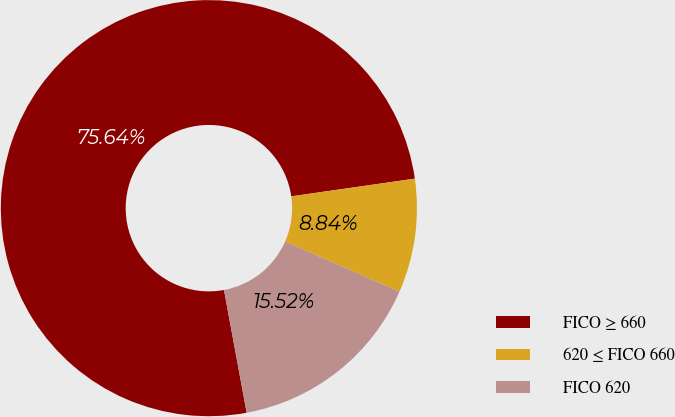Convert chart to OTSL. <chart><loc_0><loc_0><loc_500><loc_500><pie_chart><fcel>FICO ≥ 660<fcel>620 ≤ FICO 660<fcel>FICO 620<nl><fcel>75.64%<fcel>8.84%<fcel>15.52%<nl></chart> 